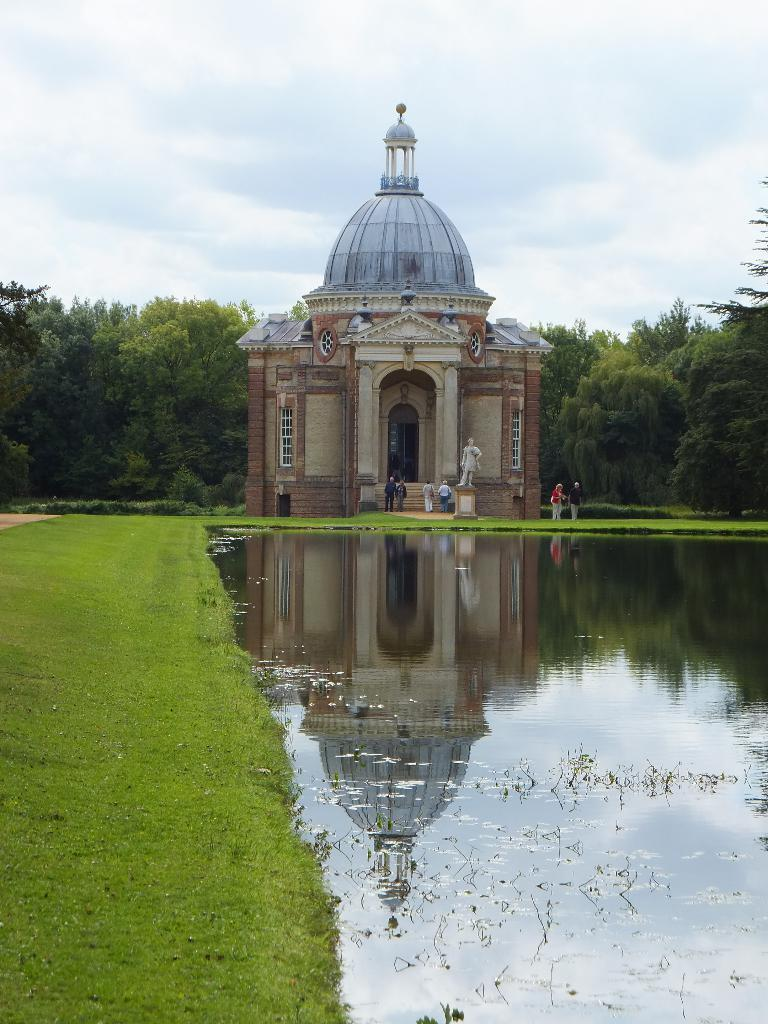What type of house is shown in the image? There is a house with a dome roof in the image. What is located in front of the house? There is a small water pond in front of the house. What can be seen on the left side of the house? There is a grass lawn on the left side of the house. What is visible in the background of the image? There are trees in the background of the image. What type of coast can be seen near the house in the image? There is no coast visible in the image; it features a house with a dome roof, a water pond, a grass lawn, and trees in the background. 